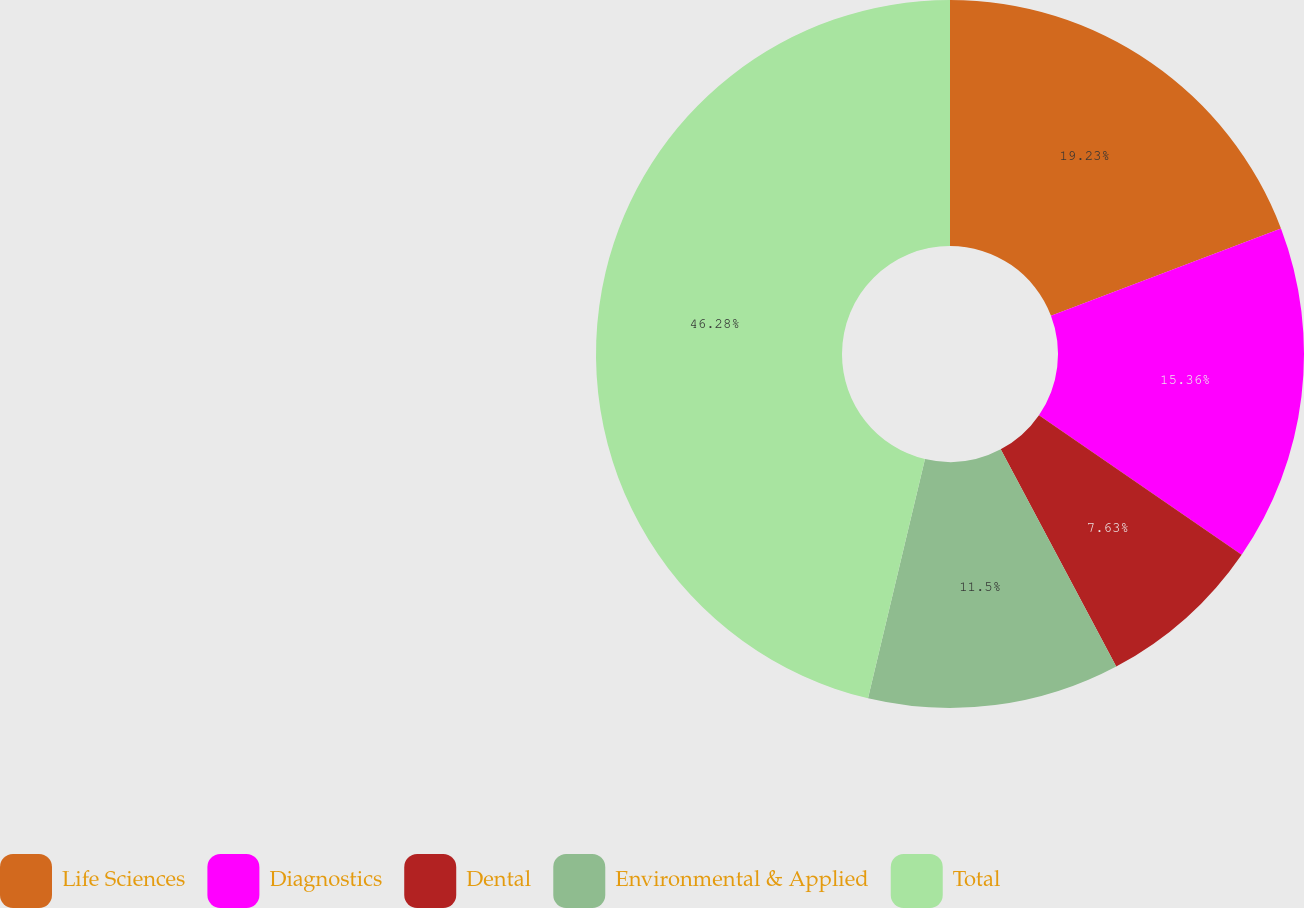<chart> <loc_0><loc_0><loc_500><loc_500><pie_chart><fcel>Life Sciences<fcel>Diagnostics<fcel>Dental<fcel>Environmental & Applied<fcel>Total<nl><fcel>19.23%<fcel>15.36%<fcel>7.63%<fcel>11.5%<fcel>46.28%<nl></chart> 